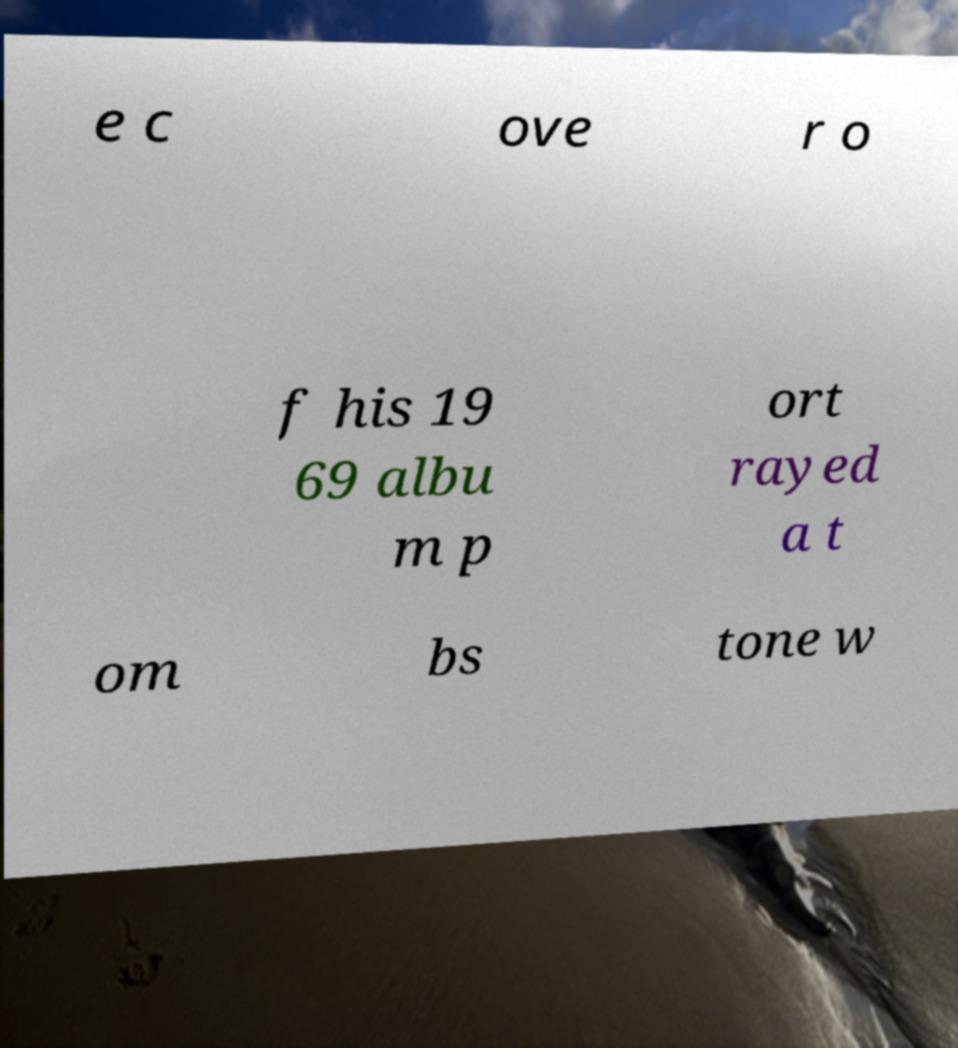Could you assist in decoding the text presented in this image and type it out clearly? e c ove r o f his 19 69 albu m p ort rayed a t om bs tone w 